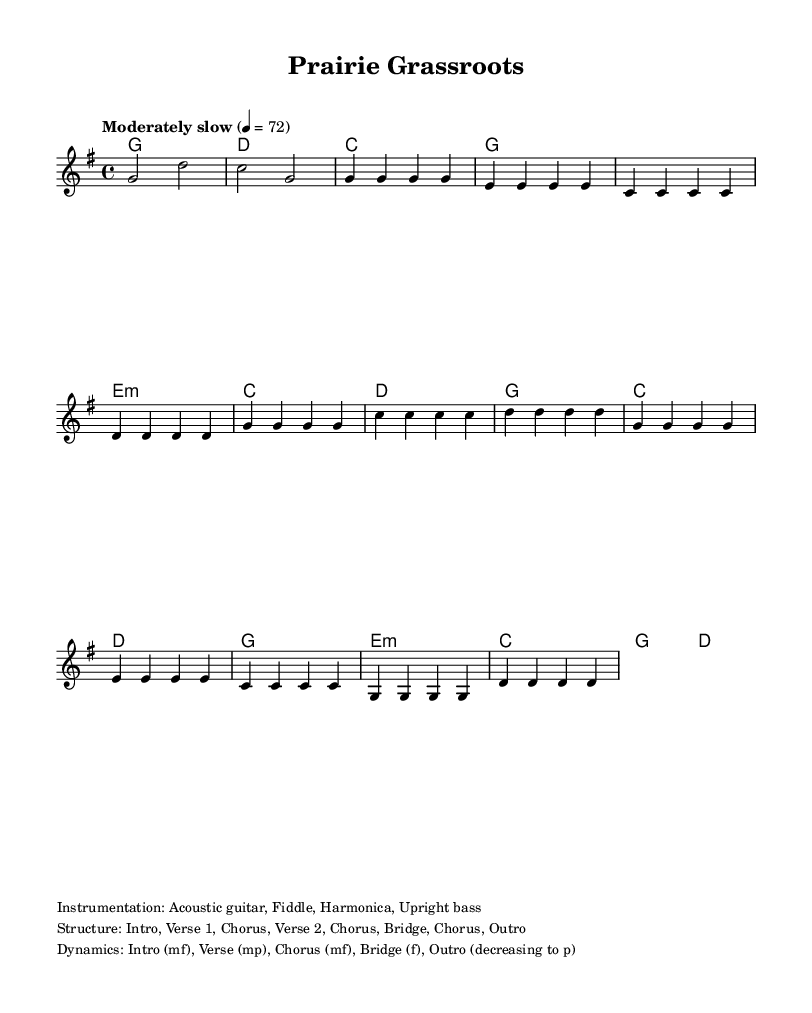What is the key signature of this music? The key signature indicates G major, which has one sharp (F#).
Answer: G major What is the time signature of the piece? The time signature is given as 4/4, meaning there are four beats per measure and a quarter note gets one beat.
Answer: 4/4 What is the tempo marking in this piece? The tempo marking is indicated as "Moderately slow" with a specific metronome mark of 72 beats per minute.
Answer: Moderately slow How many verses are present in the structure of the song? The structure outlines two verses, as indicated by the repeated sections labeled as "Verse 1" and "Verse 2."
Answer: 2 What dynamics change occurs during the bridge section? The bridge is marked as "f" indicating it should be played loudly, contrasting with the softer dynamic of the preceding verse.
Answer: f What instruments are utilized in the arrangement? The instrumentation is listed, which includes acoustic guitar, fiddle, harmonica, and upright bass, contributing to the Americana style.
Answer: Acoustic guitar, fiddle, harmonica, upright bass Which chord is played during the intro? The intro starts with a G major chord, establishing the tonal center of the piece right from the beginning.
Answer: G major 